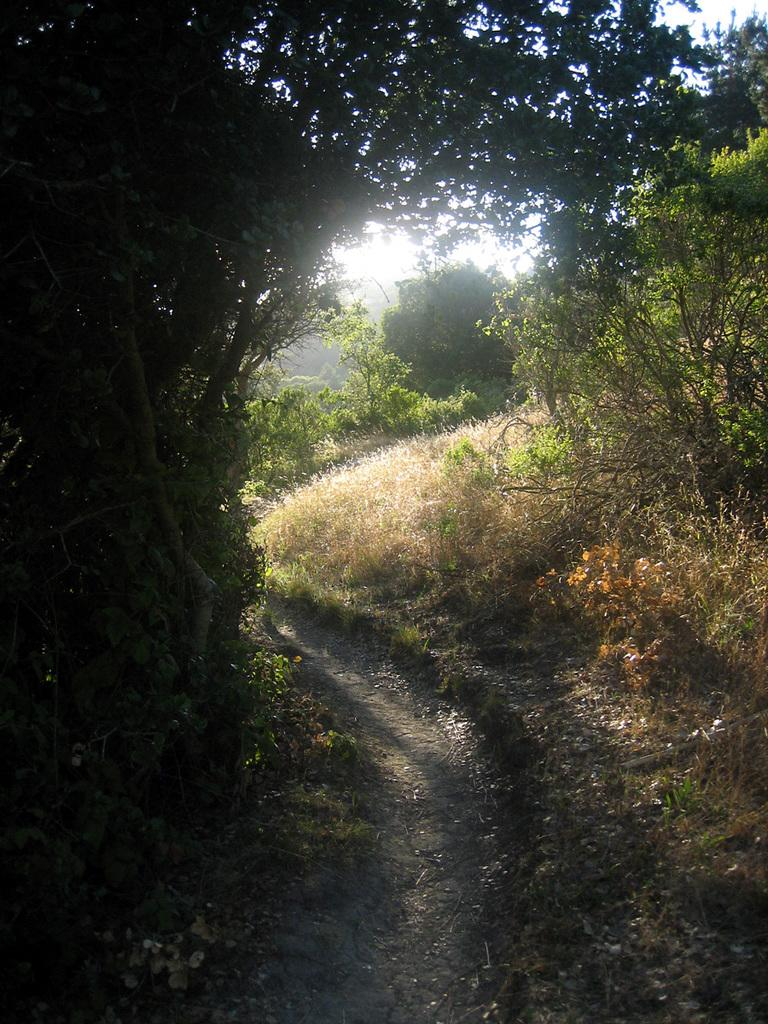What type of vegetation can be seen in the image? There are trees in the image. What is present at the bottom of the image? There is grass at the bottom of the image. What can be seen in the background of the image? The sky is visible in the background of the image. What type of window can be seen in the image? There is no window present in the image; it features trees, grass, and the sky. Is there a ring visible in the image? There is there a reward being offered in the image? 